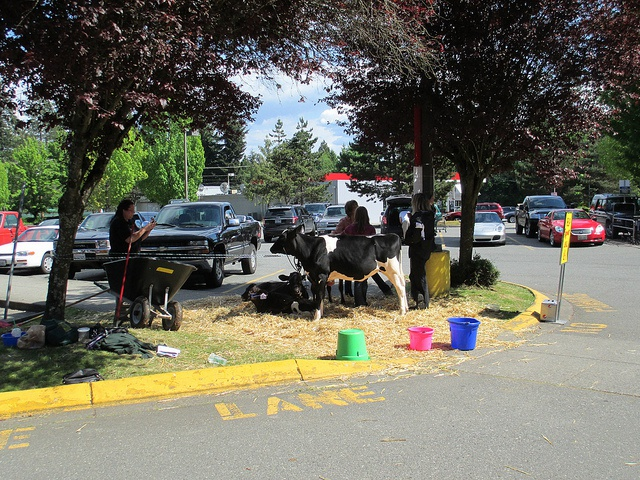Describe the objects in this image and their specific colors. I can see truck in black, gray, darkgray, and blue tones, car in black, gray, and darkgray tones, cow in black, gray, white, and tan tones, people in black, gray, and darkgray tones, and car in black, white, darkgray, and gray tones in this image. 